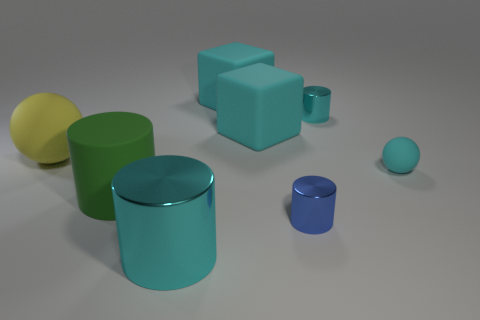Subtract all green rubber cylinders. How many cylinders are left? 3 Subtract 1 cylinders. How many cylinders are left? 3 Add 1 large green matte cylinders. How many objects exist? 9 Subtract all cubes. How many objects are left? 6 Subtract all cyan cylinders. How many cylinders are left? 2 Subtract all cyan balls. Subtract all red blocks. How many balls are left? 1 Subtract all blue balls. How many yellow cylinders are left? 0 Subtract 1 yellow balls. How many objects are left? 7 Subtract all small cylinders. Subtract all tiny cyan objects. How many objects are left? 4 Add 5 blue shiny cylinders. How many blue shiny cylinders are left? 6 